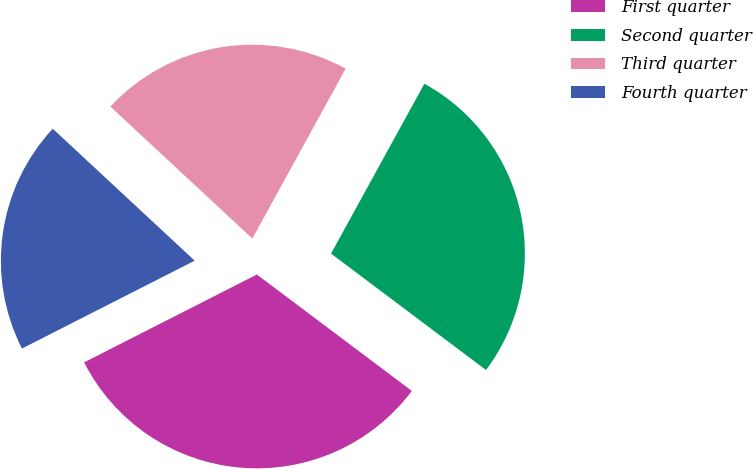<chart> <loc_0><loc_0><loc_500><loc_500><pie_chart><fcel>First quarter<fcel>Second quarter<fcel>Third quarter<fcel>Fourth quarter<nl><fcel>32.26%<fcel>27.26%<fcel>21.08%<fcel>19.41%<nl></chart> 